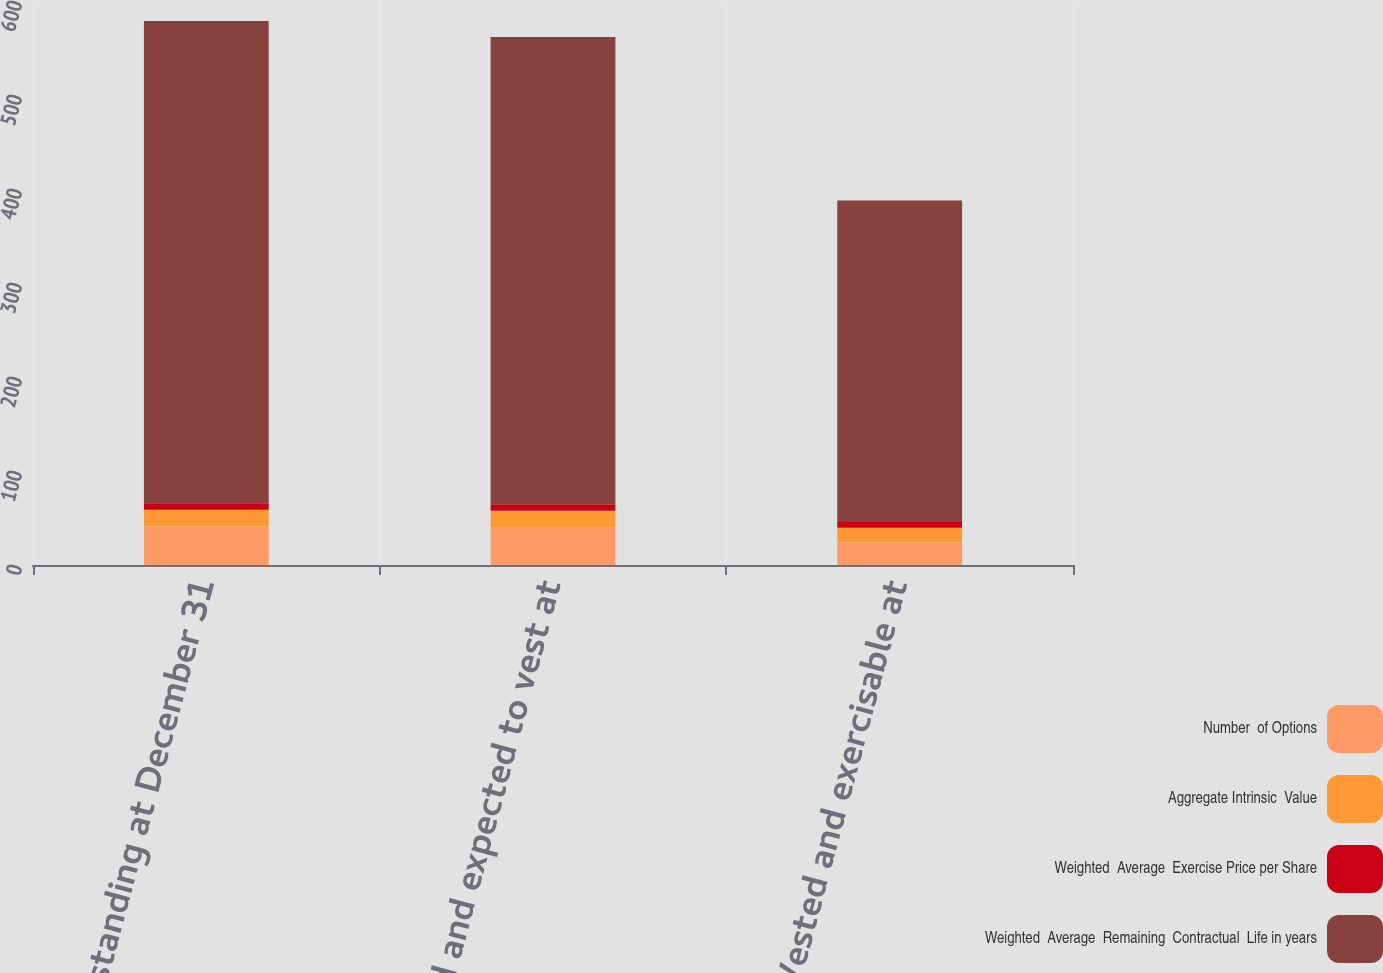<chart> <loc_0><loc_0><loc_500><loc_500><stacked_bar_chart><ecel><fcel>Outstanding at December 31<fcel>Vested and expected to vest at<fcel>Vested and exercisable at<nl><fcel>Number  of Options<fcel>41<fcel>40<fcel>24<nl><fcel>Aggregate Intrinsic  Value<fcel>17.74<fcel>17.62<fcel>15.76<nl><fcel>Weighted  Average  Exercise Price per Share<fcel>7.02<fcel>6.96<fcel>5.92<nl><fcel>Weighted  Average  Remaining  Contractual  Life in years<fcel>513<fcel>497<fcel>342<nl></chart> 